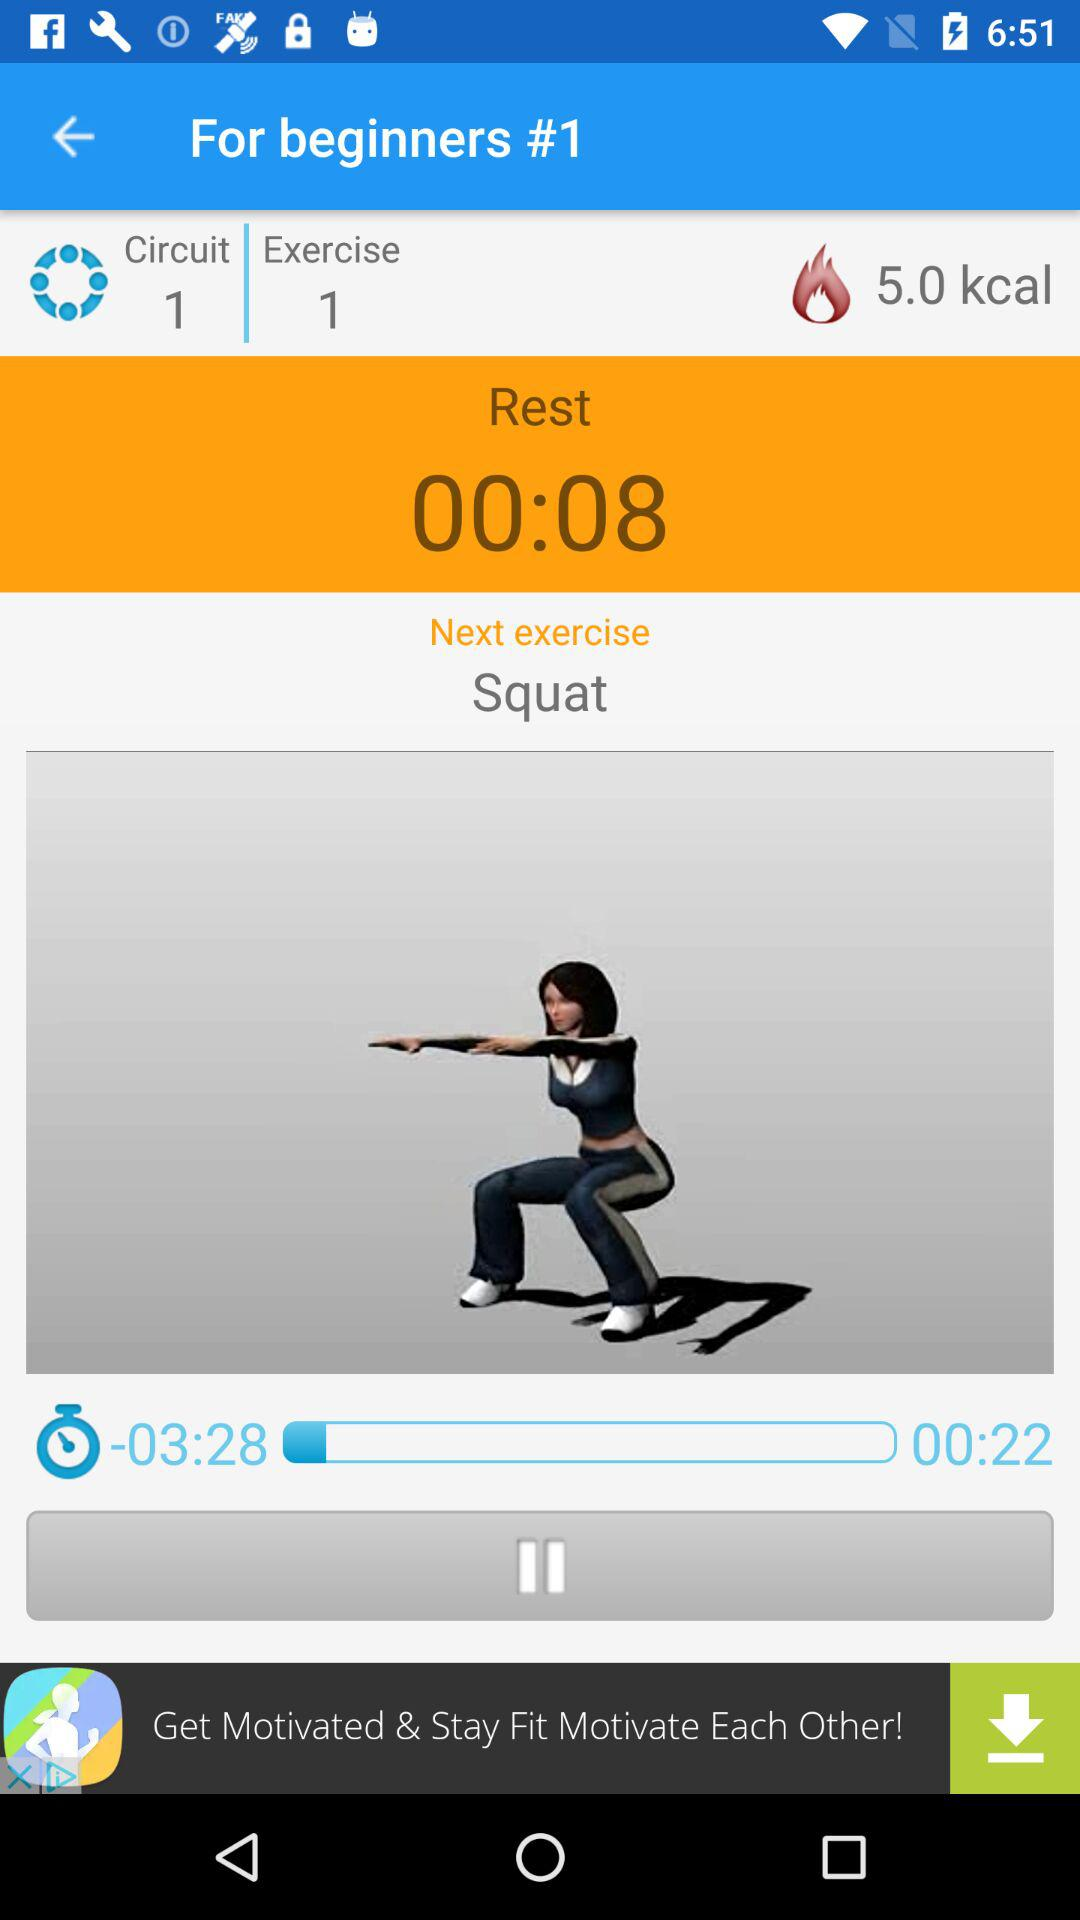How many squats does it take to burn 10 calories?
When the provided information is insufficient, respond with <no answer>. <no answer> 